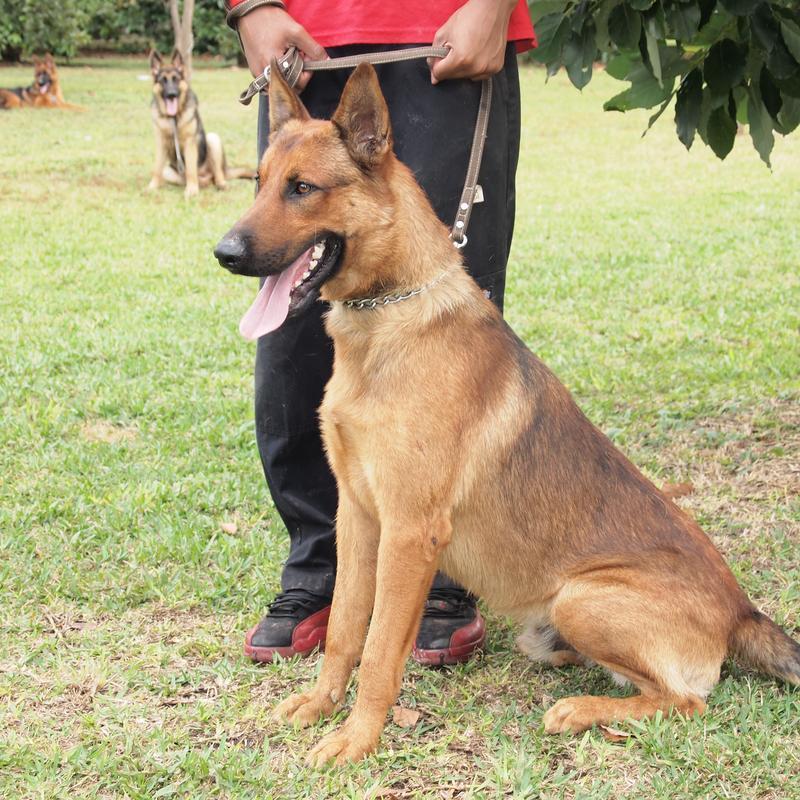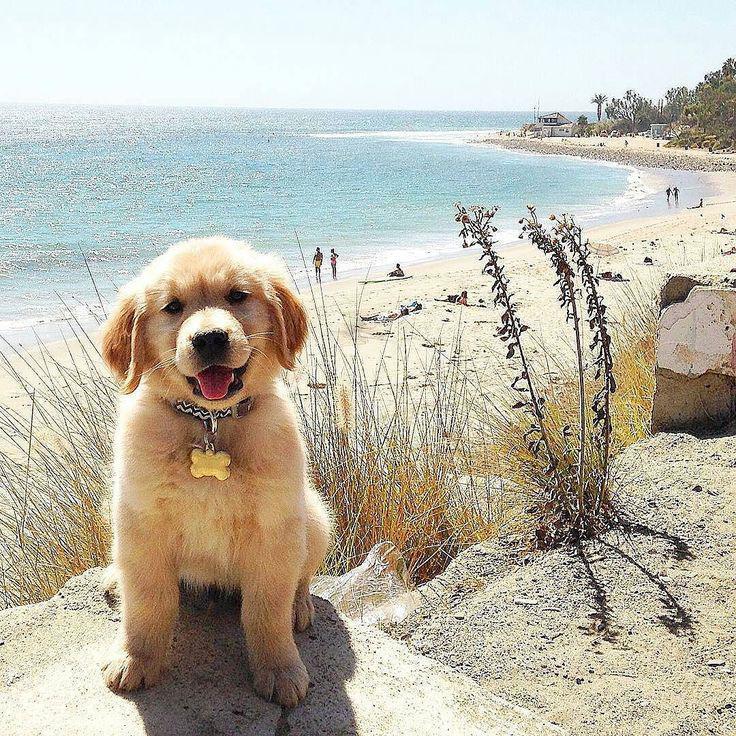The first image is the image on the left, the second image is the image on the right. For the images displayed, is the sentence "In one of the images, a dog is wearing a leash attached to a collar" factually correct? Answer yes or no. Yes. 